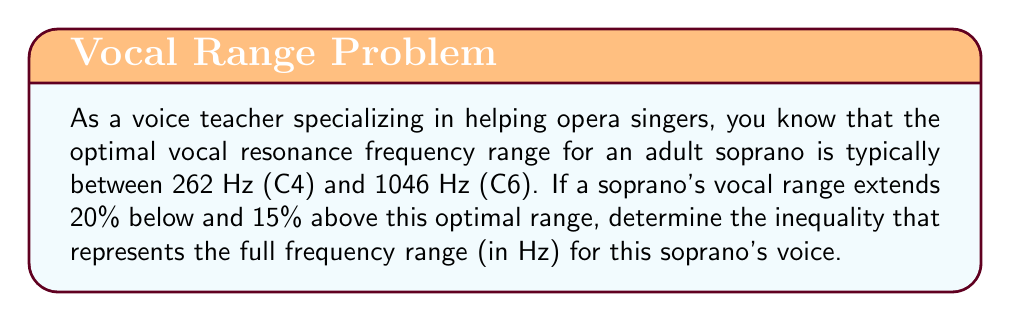Could you help me with this problem? Let's approach this step-by-step:

1) First, let's define our variables:
   Let $f$ represent the frequency in Hz.

2) The given optimal range is 262 Hz to 1046 Hz. We can write this as:
   $262 \leq f \leq 1046$

3) Now, we need to extend this range:
   - 20% below the lower limit
   - 15% above the upper limit

4) For the lower limit:
   $262 - (20\% \text{ of } 262) = 262 - (0.20 \times 262) = 262 - 52.4 = 209.6$ Hz

5) For the upper limit:
   $1046 + (15\% \text{ of } 1046) = 1046 + (0.15 \times 1046) = 1046 + 156.9 = 1202.9$ Hz

6) Therefore, the full range can be represented by the inequality:
   $209.6 \leq f \leq 1202.9$

This inequality represents the extended frequency range for the soprano's voice, including the areas just outside the optimal resonance range.
Answer: $209.6 \leq f \leq 1202.9$, where $f$ is the frequency in Hz. 